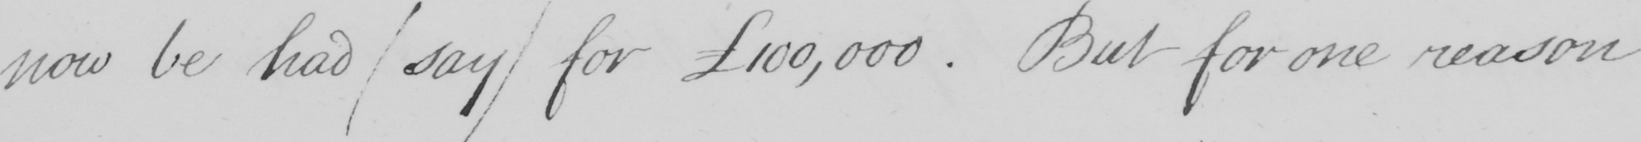Can you tell me what this handwritten text says? now be had  ( say )  for 100,000 . But for one reason 